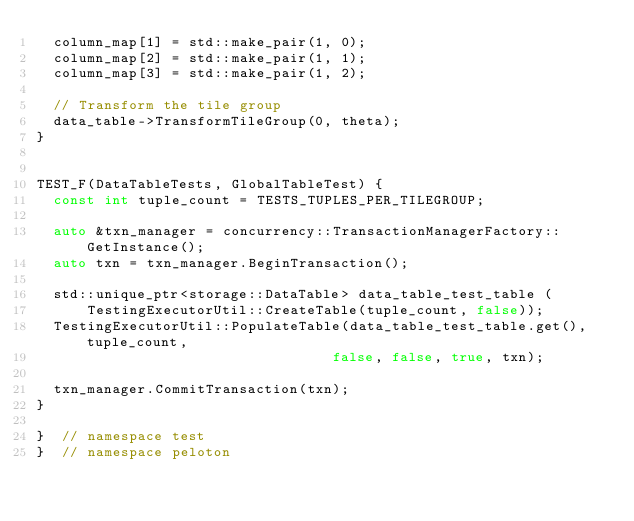Convert code to text. <code><loc_0><loc_0><loc_500><loc_500><_C++_>  column_map[1] = std::make_pair(1, 0);
  column_map[2] = std::make_pair(1, 1);
  column_map[3] = std::make_pair(1, 2);

  // Transform the tile group
  data_table->TransformTileGroup(0, theta);
}


TEST_F(DataTableTests, GlobalTableTest) {
  const int tuple_count = TESTS_TUPLES_PER_TILEGROUP;

  auto &txn_manager = concurrency::TransactionManagerFactory::GetInstance();
  auto txn = txn_manager.BeginTransaction();

  std::unique_ptr<storage::DataTable> data_table_test_table (
      TestingExecutorUtil::CreateTable(tuple_count, false));
  TestingExecutorUtil::PopulateTable(data_table_test_table.get(), tuple_count,
                                   false, false, true, txn);

  txn_manager.CommitTransaction(txn);
}

}  // namespace test
}  // namespace peloton
</code> 